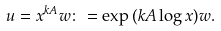Convert formula to latex. <formula><loc_0><loc_0><loc_500><loc_500>u = x ^ { k A } w \colon = \exp { ( k A \log x ) } w .</formula> 